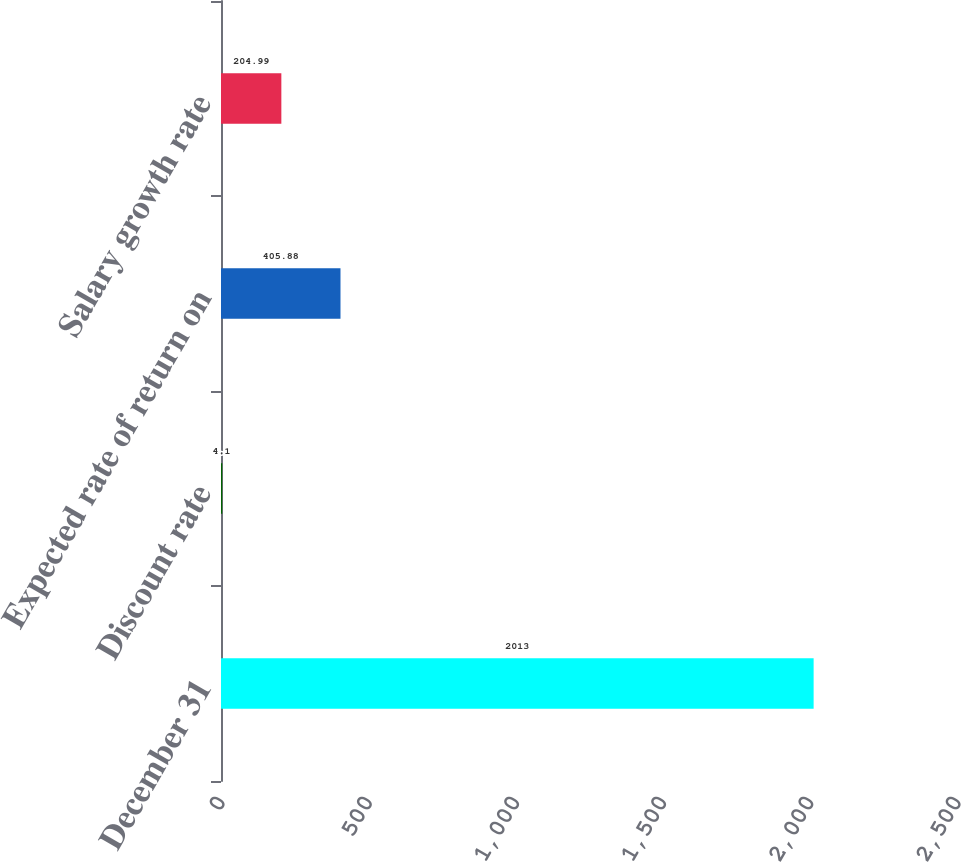Convert chart. <chart><loc_0><loc_0><loc_500><loc_500><bar_chart><fcel>December 31<fcel>Discount rate<fcel>Expected rate of return on<fcel>Salary growth rate<nl><fcel>2013<fcel>4.1<fcel>405.88<fcel>204.99<nl></chart> 